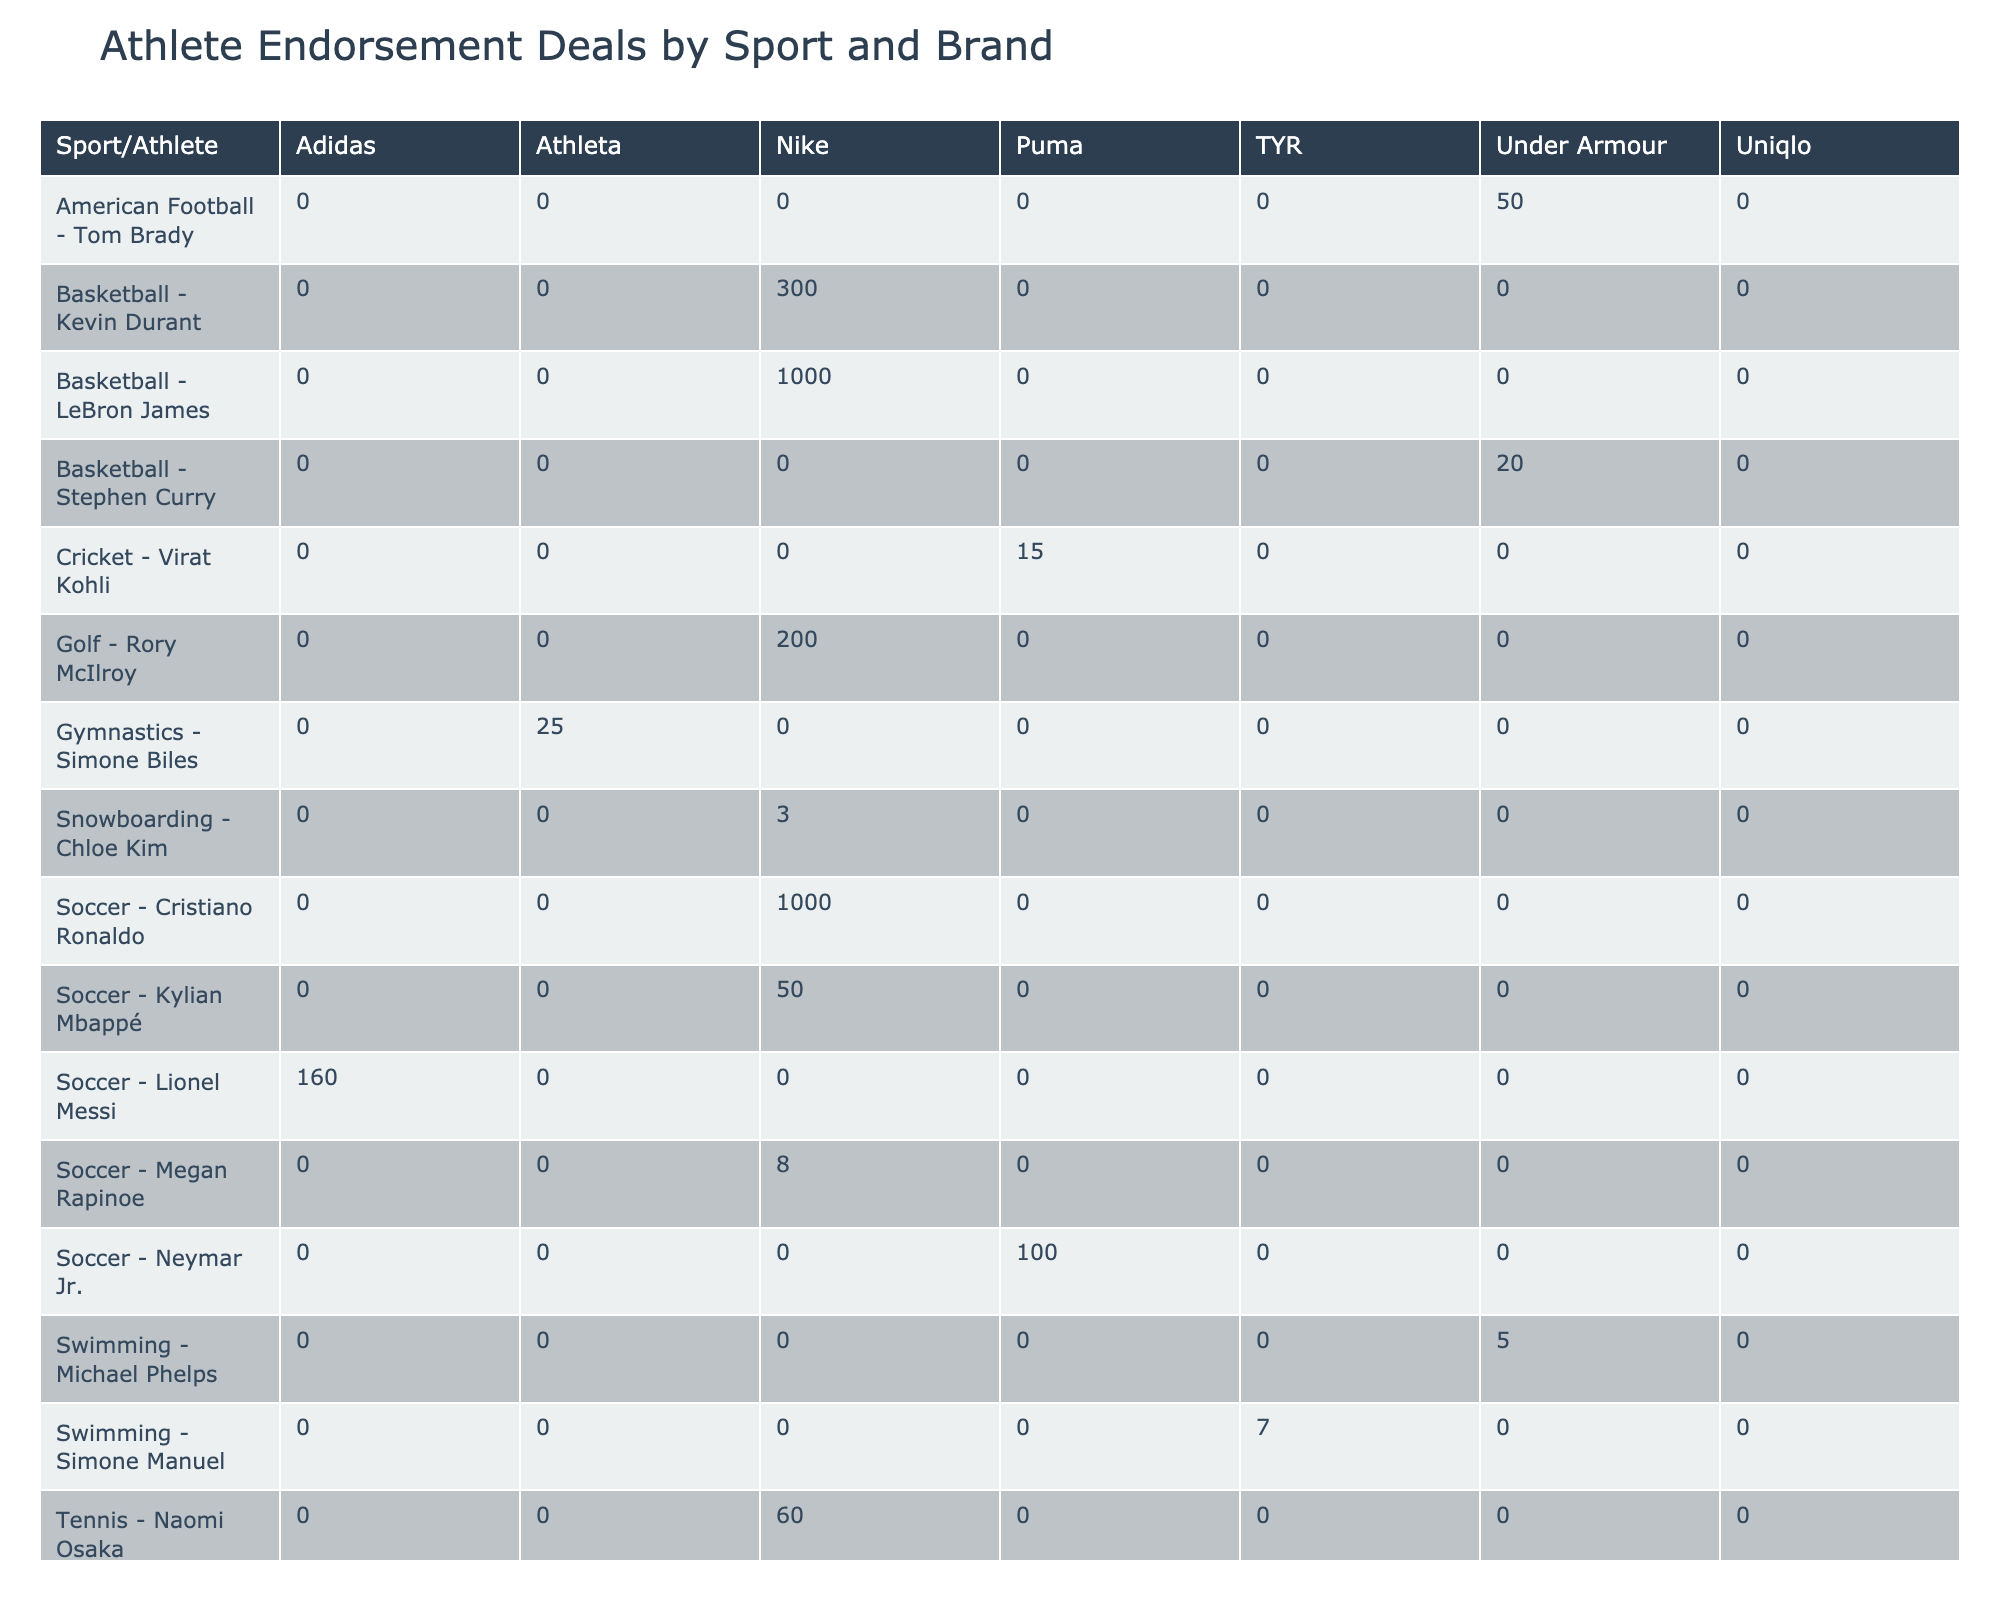What is the highest endorsement deal value listed in the table? The highest deal value is found by scanning through the "Deal Value ($M)" column for the maximum number. The highest value is 1000, associated with both LeBron James and Cristiano Ronaldo.
Answer: 1000 Which athlete has the longest contract length? To find the longest contract length, I compare the "Contract Length (Years)" for all athletes. The maximum length in this column is "Lifetime", which appears for LeBron James, Cristiano Ronaldo, and Lionel Messi.
Answer: Lifetime What is the total deal value for Nike across all athletes? I will sum the deal values for all entries where the brand is Nike. The total comes from the values: 1000 (LeBron James) + 1000 (Cristiano Ronaldo) + 40 (Serena Williams) + 10 (Rafael Nadal) + 60 (Naomi Osaka) + 300 (Kevin Durant) + 3 (Chloe Kim) = 2413.
Answer: 2413 Is there any athlete with a deal value greater than 200 million? By examining the "Deal Value ($M)" column, I see that LeBron James (1000), Cristiano Ronaldo (1000), Lionel Messi (160), Roger Federer (300), and Kevin Durant (300) have deal values above 200 million. This means there are athletes with deals exceeding 200 million.
Answer: Yes Which sport has the highest average endorsement deal value? To find the highest average, I first group athletes by sport and calculate the average deal value for each group. The averages are: Basketball = (1000 + 20 + 300)/3 = 440, Soccer = (1000 + 160 + 100 + 50)/4 = 577.5, Tennis = (40 + 300 + 10 + 60)/4 = 102.5, etc. The highest average is for Soccer at 577.5 million.
Answer: Soccer What is the performance bonus for the athlete with the most social media followers? I need to check the "Social Media Followers (M)" column and identify the athlete with the highest number, which is Cristiano Ronaldo with 500 million followers. The corresponding "Performance Bonus ($M)" for Ronaldo is 75.
Answer: 75 Calculate the total performance bonus for athletes in Gymnastics and Swimming. I will sum the performance bonuses for athletes listed under Gymnastics (Simone Biles = 8) and Swimming (Michael Phelps = 2, Simone Manuel = 2). The total is 8 + 2 + 2 = 12.
Answer: 12 